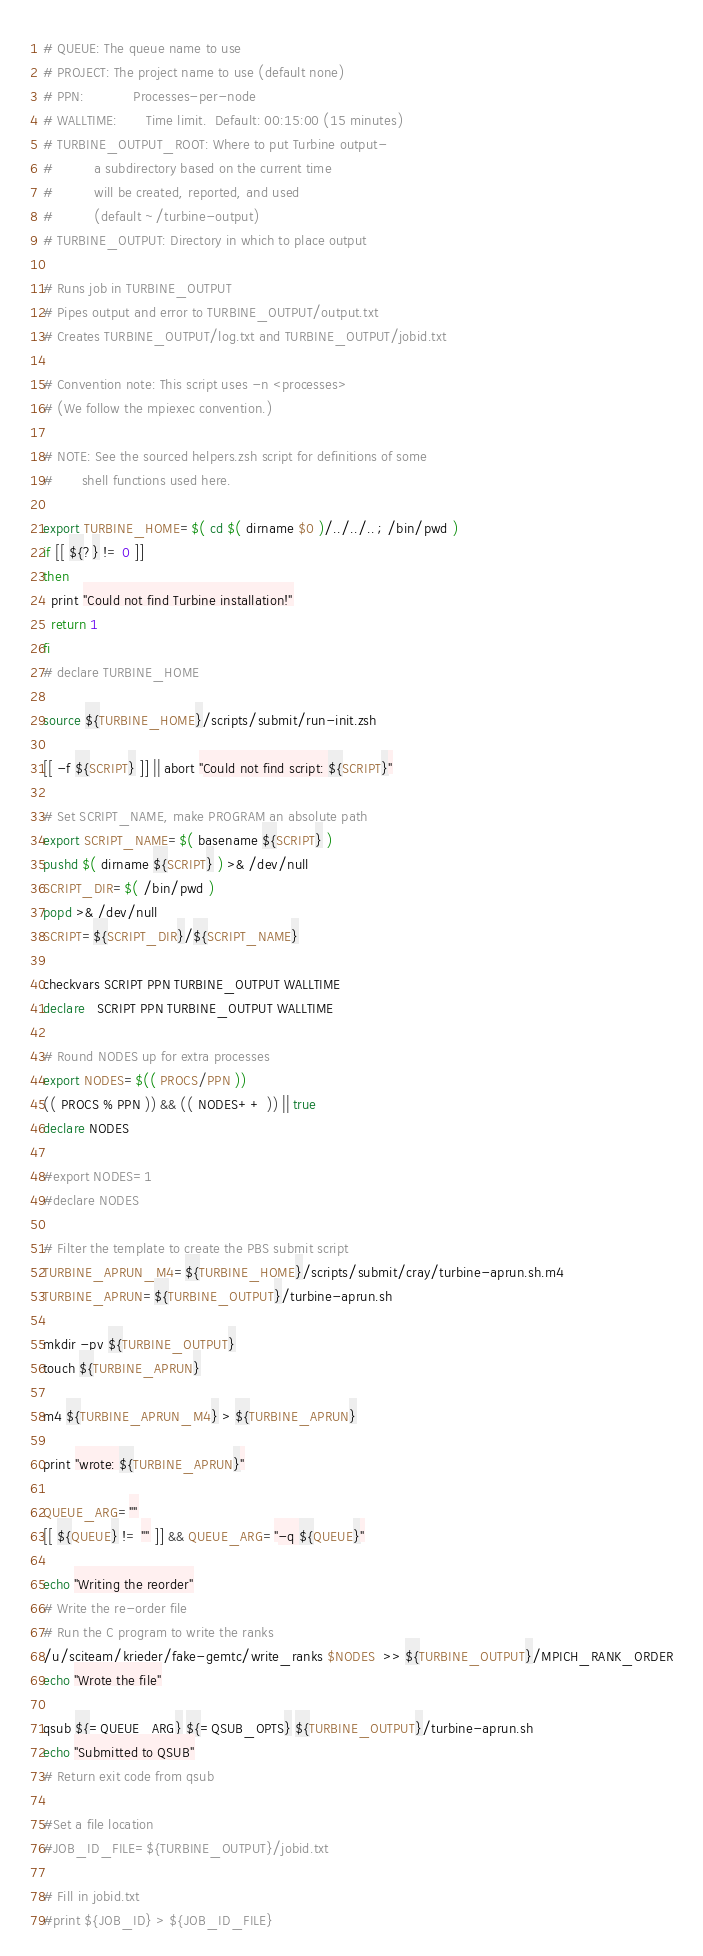Convert code to text. <code><loc_0><loc_0><loc_500><loc_500><_Bash_># QUEUE: The queue name to use
# PROJECT: The project name to use (default none)
# PPN:            Processes-per-node
# WALLTIME:       Time limit.  Default: 00:15:00 (15 minutes)
# TURBINE_OUTPUT_ROOT: Where to put Turbine output-
#          a subdirectory based on the current time
#          will be created, reported, and used
#          (default ~/turbine-output)
# TURBINE_OUTPUT: Directory in which to place output

# Runs job in TURBINE_OUTPUT
# Pipes output and error to TURBINE_OUTPUT/output.txt
# Creates TURBINE_OUTPUT/log.txt and TURBINE_OUTPUT/jobid.txt

# Convention note: This script uses -n <processes>
# (We follow the mpiexec convention.)

# NOTE: See the sourced helpers.zsh script for definitions of some
#       shell functions used here.

export TURBINE_HOME=$( cd $( dirname $0 )/../../.. ; /bin/pwd )
if [[ ${?} != 0 ]]
then
  print "Could not find Turbine installation!"
  return 1
fi
# declare TURBINE_HOME

source ${TURBINE_HOME}/scripts/submit/run-init.zsh

[[ -f ${SCRIPT} ]] || abort "Could not find script: ${SCRIPT}"

# Set SCRIPT_NAME, make PROGRAM an absolute path
export SCRIPT_NAME=$( basename ${SCRIPT} )
pushd $( dirname ${SCRIPT} ) >& /dev/null
SCRIPT_DIR=$( /bin/pwd )
popd >& /dev/null
SCRIPT=${SCRIPT_DIR}/${SCRIPT_NAME}

checkvars SCRIPT PPN TURBINE_OUTPUT WALLTIME
declare   SCRIPT PPN TURBINE_OUTPUT WALLTIME

# Round NODES up for extra processes
export NODES=$(( PROCS/PPN ))
(( PROCS % PPN )) && (( NODES++ )) || true
declare NODES

#export NODES=1
#declare NODES

# Filter the template to create the PBS submit script
TURBINE_APRUN_M4=${TURBINE_HOME}/scripts/submit/cray/turbine-aprun.sh.m4
TURBINE_APRUN=${TURBINE_OUTPUT}/turbine-aprun.sh

mkdir -pv ${TURBINE_OUTPUT}
touch ${TURBINE_APRUN}

m4 ${TURBINE_APRUN_M4} > ${TURBINE_APRUN}

print "wrote: ${TURBINE_APRUN}"

QUEUE_ARG=""
[[ ${QUEUE} != "" ]] && QUEUE_ARG="-q ${QUEUE}"

echo "Writing the reorder"
# Write the re-order file
# Run the C program to write the ranks
/u/sciteam/krieder/fake-gemtc/write_ranks $NODES  >> ${TURBINE_OUTPUT}/MPICH_RANK_ORDER
echo "Wrote the file"

qsub ${=QUEUE_ARG} ${=QSUB_OPTS} ${TURBINE_OUTPUT}/turbine-aprun.sh 
echo "Submitted to QSUB"
# Return exit code from qsub

#Set a file location
#JOB_ID_FILE=${TURBINE_OUTPUT}/jobid.txt

# Fill in jobid.txt                                                                                           
#print ${JOB_ID} > ${JOB_ID_FILE}
</code> 